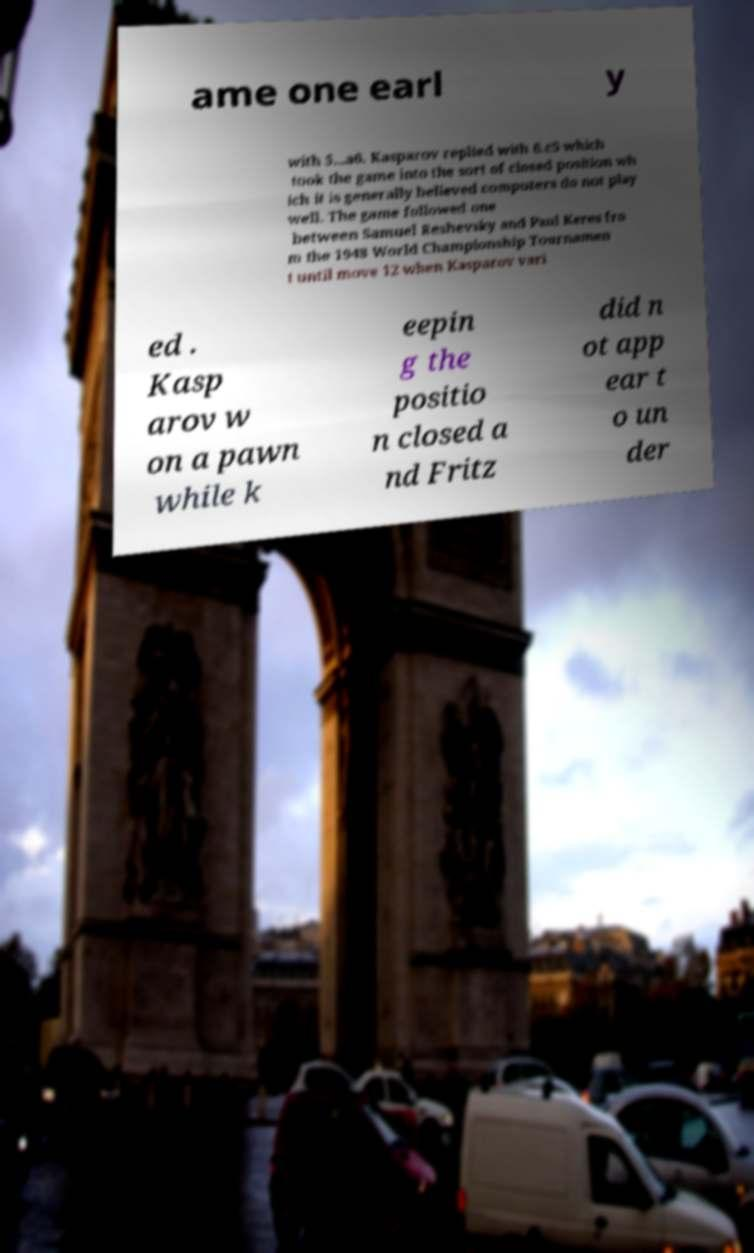There's text embedded in this image that I need extracted. Can you transcribe it verbatim? ame one earl y with 5...a6. Kasparov replied with 6.c5 which took the game into the sort of closed position wh ich it is generally believed computers do not play well. The game followed one between Samuel Reshevsky and Paul Keres fro m the 1948 World Championship Tournamen t until move 12 when Kasparov vari ed . Kasp arov w on a pawn while k eepin g the positio n closed a nd Fritz did n ot app ear t o un der 